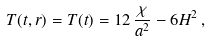Convert formula to latex. <formula><loc_0><loc_0><loc_500><loc_500>T ( t , r ) = T ( t ) = 1 2 \, \frac { \chi } { a ^ { 2 } } - 6 H ^ { 2 } \, ,</formula> 